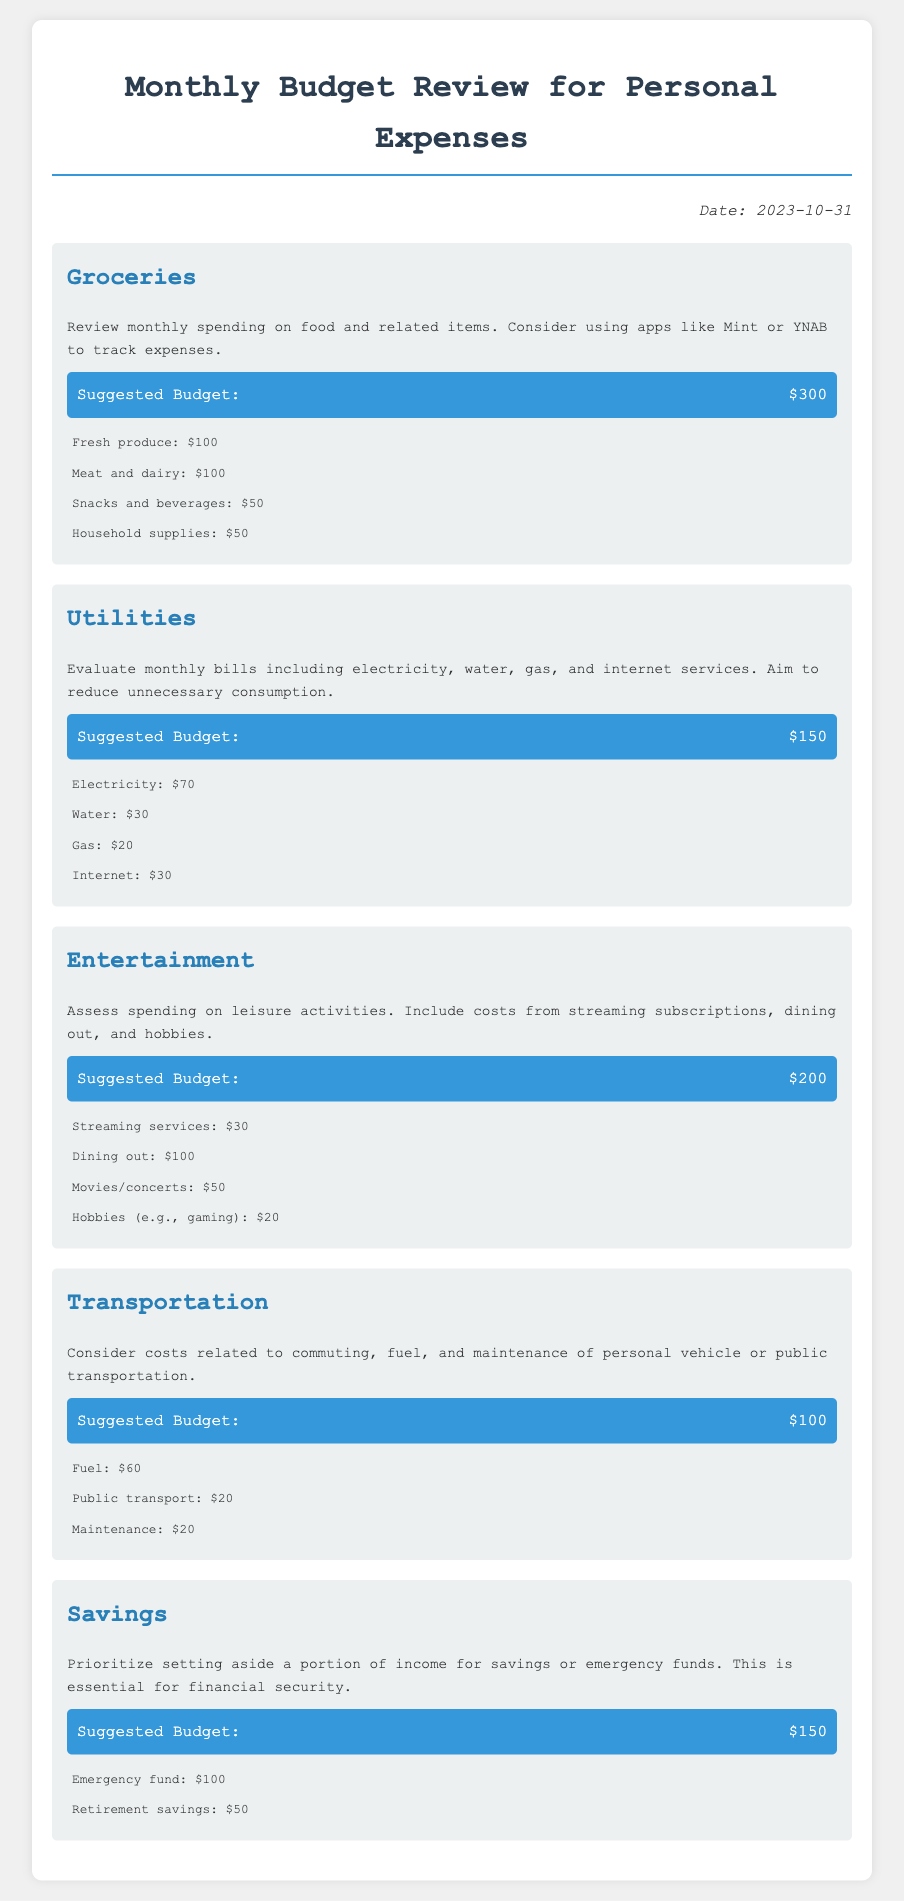what is the total suggested budget for groceries? The total suggested budget for groceries is explicitly stated in the document as $300.
Answer: $300 how much is allocated for utilities? The document shows that $150 is the suggested budget for utilities.
Answer: $150 what percentage of the transportation budget is for fuel? The budget for fuel is $60 out of a $100 total for transportation, which is 60%.
Answer: 60% how much is set aside for emergency funds? The document indicates that $100 is allocated for emergency funds under savings.
Answer: $100 which category has the highest budget allocation? The category with the highest budget allocation is entertainment, with a suggested budget of $200.
Answer: entertainment what is the total amount spent on dining out? Dining out expenses are allocated $100 in the entertainment category.
Answer: $100 how much is spent on internet services as part of utilities? Internet services are listed as $30 within the utilities budget.
Answer: $30 what is the budget for household supplies? Household supplies are allocated $50 in the groceries category.
Answer: $50 how many categories are covered in the budget review? The document covers five categories: groceries, utilities, entertainment, transportation, and savings.
Answer: five 